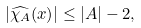Convert formula to latex. <formula><loc_0><loc_0><loc_500><loc_500>| \widehat { \chi _ { A } } ( x ) | \leq | A | - 2 ,</formula> 